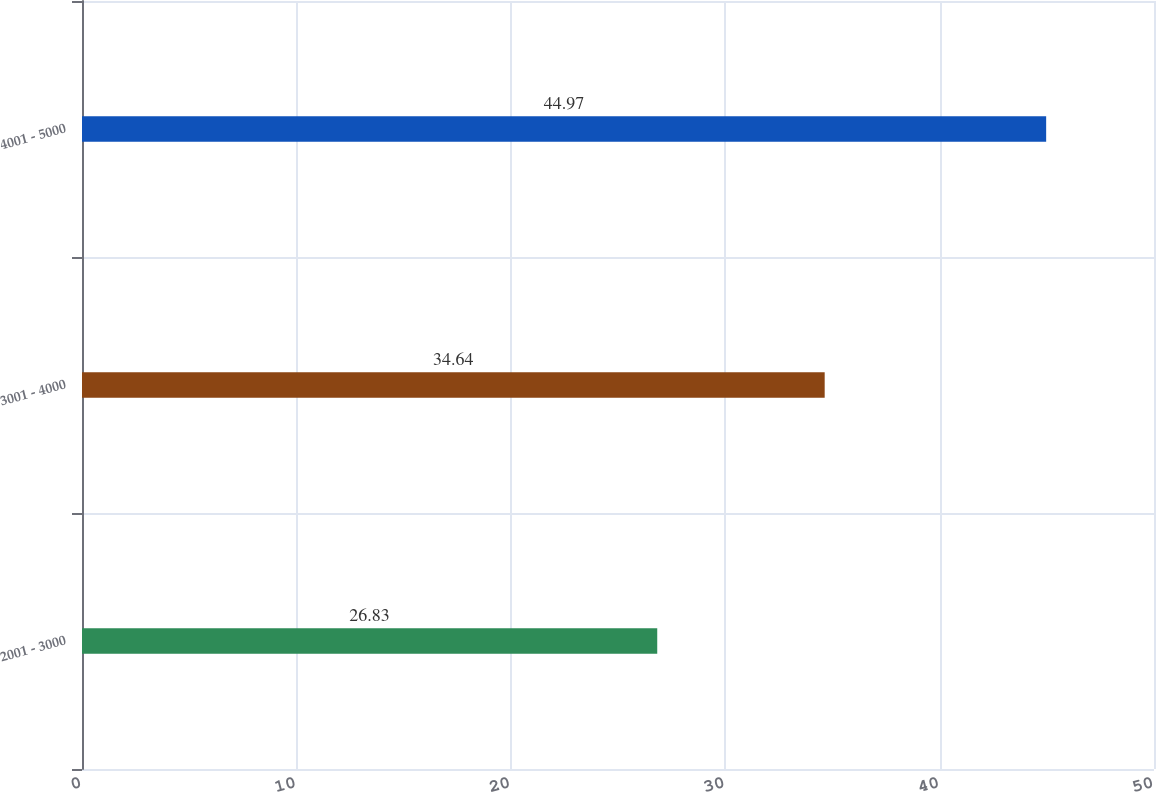Convert chart to OTSL. <chart><loc_0><loc_0><loc_500><loc_500><bar_chart><fcel>2001 - 3000<fcel>3001 - 4000<fcel>4001 - 5000<nl><fcel>26.83<fcel>34.64<fcel>44.97<nl></chart> 